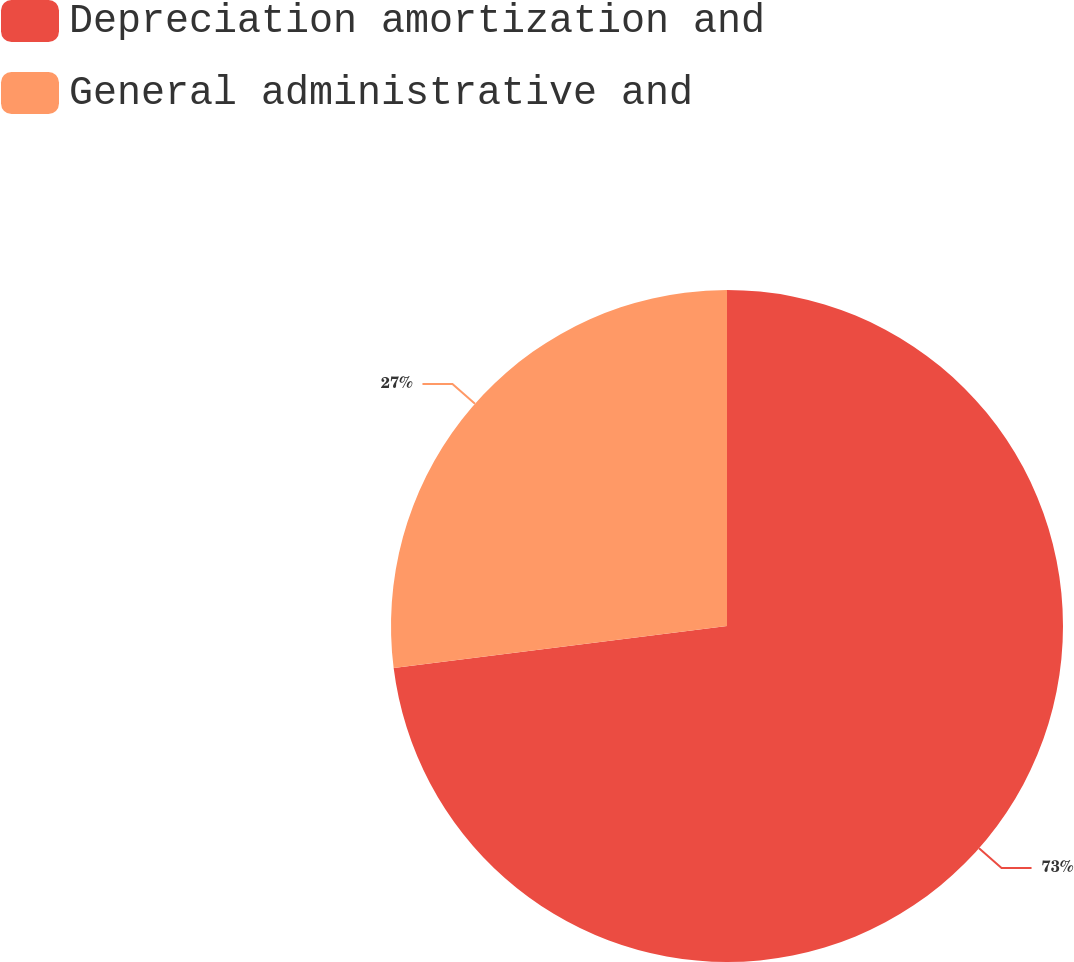Convert chart. <chart><loc_0><loc_0><loc_500><loc_500><pie_chart><fcel>Depreciation amortization and<fcel>General administrative and<nl><fcel>73.0%<fcel>27.0%<nl></chart> 